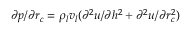<formula> <loc_0><loc_0><loc_500><loc_500>\partial p / \partial { r _ { c } } = { \rho _ { l } } { v _ { l } } ( { \partial ^ { 2 } } u / \partial { h ^ { 2 } } + { \partial ^ { 2 } } u / \partial r _ { c } ^ { 2 } )</formula> 